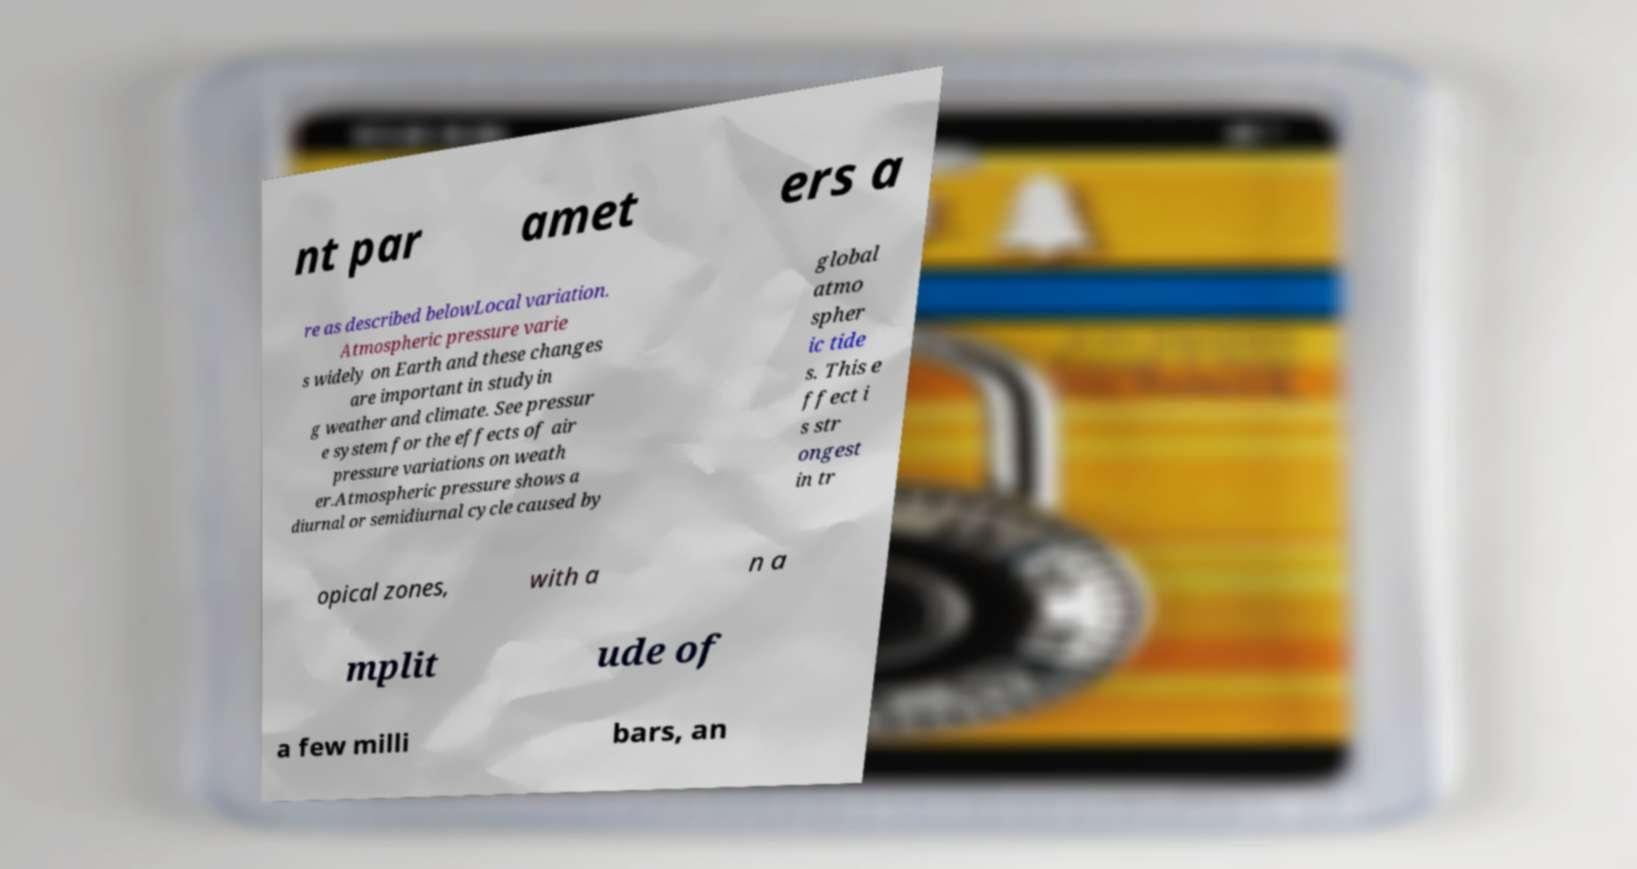Could you extract and type out the text from this image? nt par amet ers a re as described belowLocal variation. Atmospheric pressure varie s widely on Earth and these changes are important in studyin g weather and climate. See pressur e system for the effects of air pressure variations on weath er.Atmospheric pressure shows a diurnal or semidiurnal cycle caused by global atmo spher ic tide s. This e ffect i s str ongest in tr opical zones, with a n a mplit ude of a few milli bars, an 